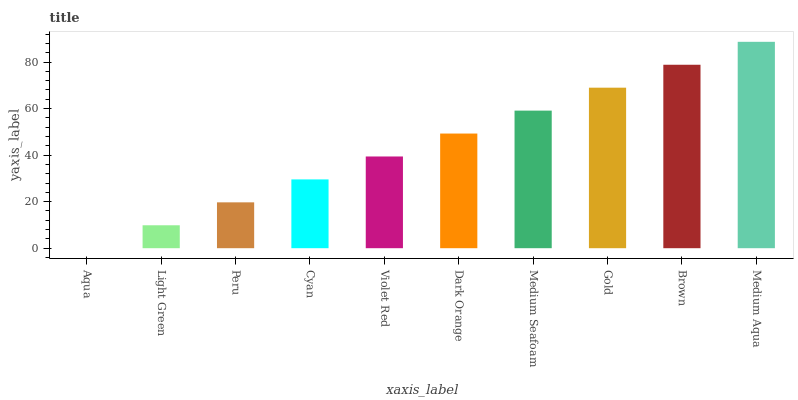Is Aqua the minimum?
Answer yes or no. Yes. Is Medium Aqua the maximum?
Answer yes or no. Yes. Is Light Green the minimum?
Answer yes or no. No. Is Light Green the maximum?
Answer yes or no. No. Is Light Green greater than Aqua?
Answer yes or no. Yes. Is Aqua less than Light Green?
Answer yes or no. Yes. Is Aqua greater than Light Green?
Answer yes or no. No. Is Light Green less than Aqua?
Answer yes or no. No. Is Dark Orange the high median?
Answer yes or no. Yes. Is Violet Red the low median?
Answer yes or no. Yes. Is Peru the high median?
Answer yes or no. No. Is Dark Orange the low median?
Answer yes or no. No. 